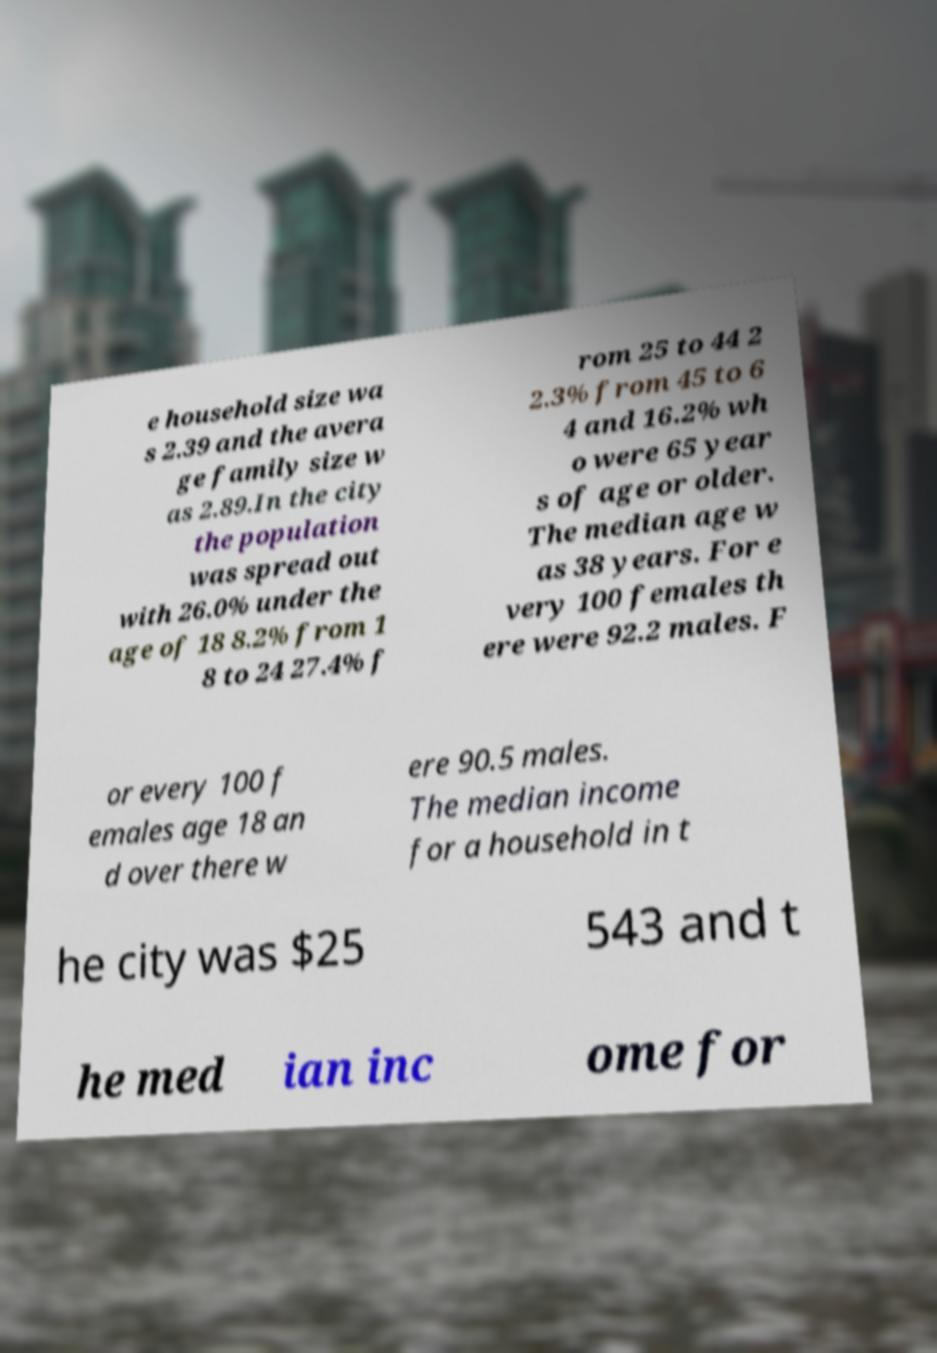Can you read and provide the text displayed in the image?This photo seems to have some interesting text. Can you extract and type it out for me? e household size wa s 2.39 and the avera ge family size w as 2.89.In the city the population was spread out with 26.0% under the age of 18 8.2% from 1 8 to 24 27.4% f rom 25 to 44 2 2.3% from 45 to 6 4 and 16.2% wh o were 65 year s of age or older. The median age w as 38 years. For e very 100 females th ere were 92.2 males. F or every 100 f emales age 18 an d over there w ere 90.5 males. The median income for a household in t he city was $25 543 and t he med ian inc ome for 